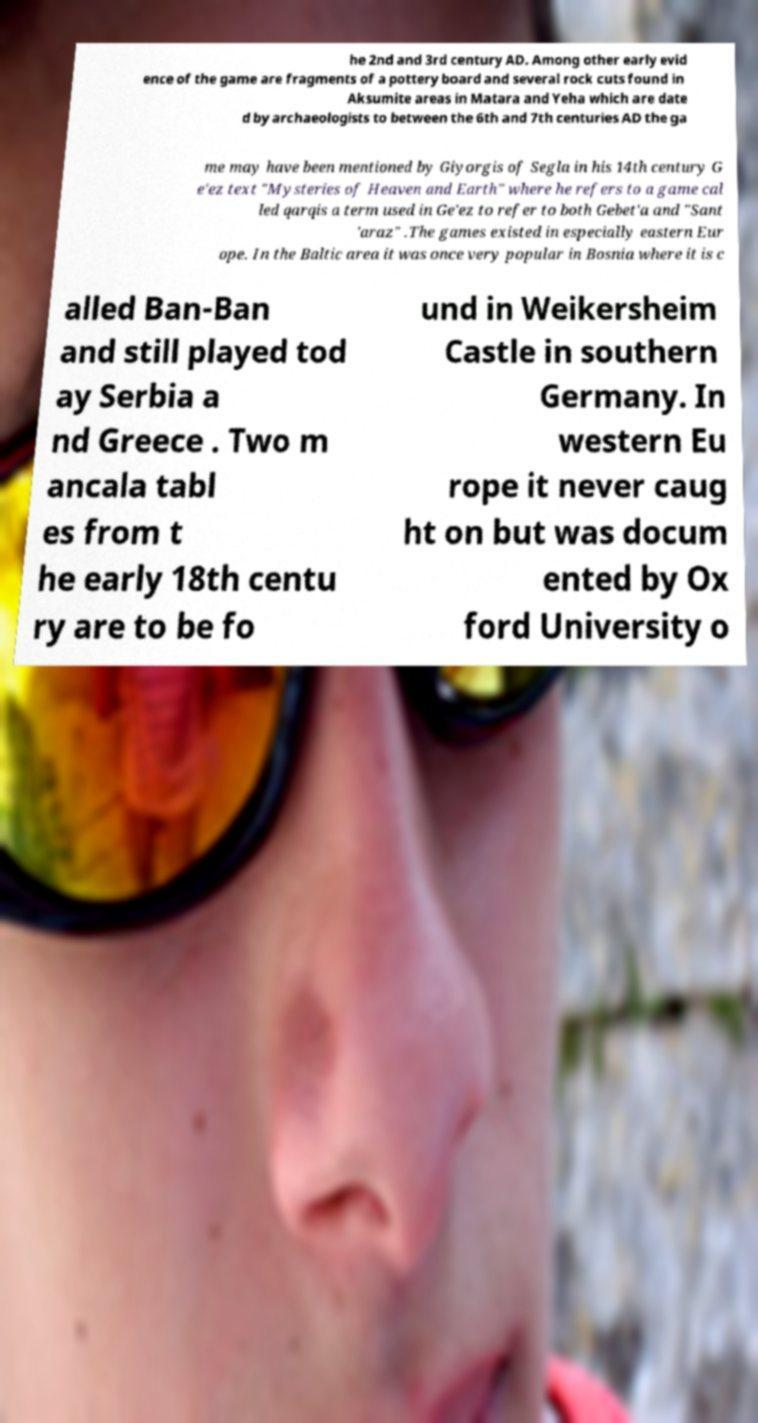Could you assist in decoding the text presented in this image and type it out clearly? he 2nd and 3rd century AD. Among other early evid ence of the game are fragments of a pottery board and several rock cuts found in Aksumite areas in Matara and Yeha which are date d by archaeologists to between the 6th and 7th centuries AD the ga me may have been mentioned by Giyorgis of Segla in his 14th century G e'ez text "Mysteries of Heaven and Earth" where he refers to a game cal led qarqis a term used in Ge'ez to refer to both Gebet'a and "Sant 'araz" .The games existed in especially eastern Eur ope. In the Baltic area it was once very popular in Bosnia where it is c alled Ban-Ban and still played tod ay Serbia a nd Greece . Two m ancala tabl es from t he early 18th centu ry are to be fo und in Weikersheim Castle in southern Germany. In western Eu rope it never caug ht on but was docum ented by Ox ford University o 